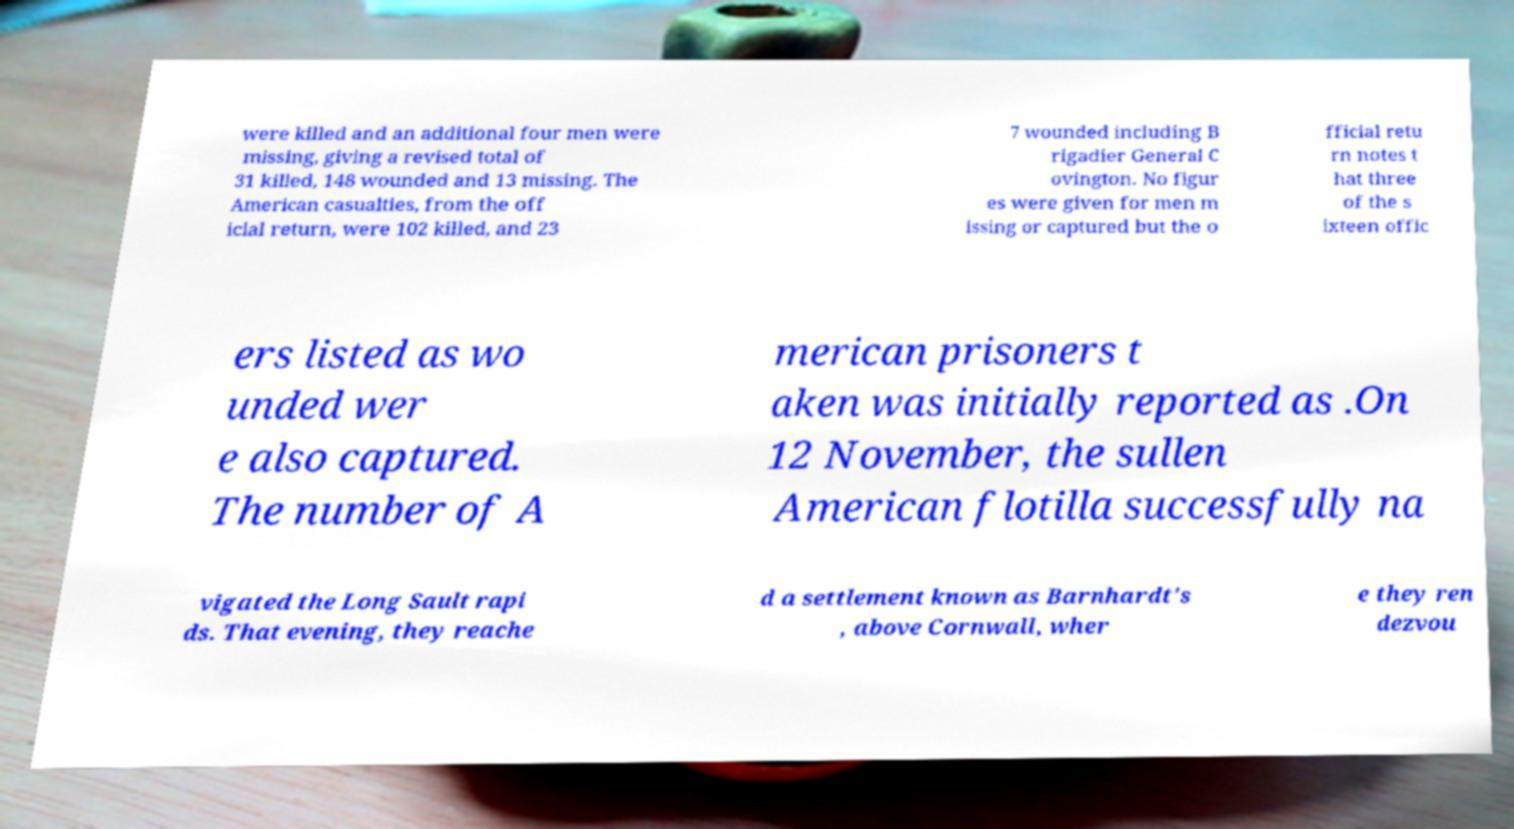Could you extract and type out the text from this image? were killed and an additional four men were missing, giving a revised total of 31 killed, 148 wounded and 13 missing. The American casualties, from the off icial return, were 102 killed, and 23 7 wounded including B rigadier General C ovington. No figur es were given for men m issing or captured but the o fficial retu rn notes t hat three of the s ixteen offic ers listed as wo unded wer e also captured. The number of A merican prisoners t aken was initially reported as .On 12 November, the sullen American flotilla successfully na vigated the Long Sault rapi ds. That evening, they reache d a settlement known as Barnhardt's , above Cornwall, wher e they ren dezvou 